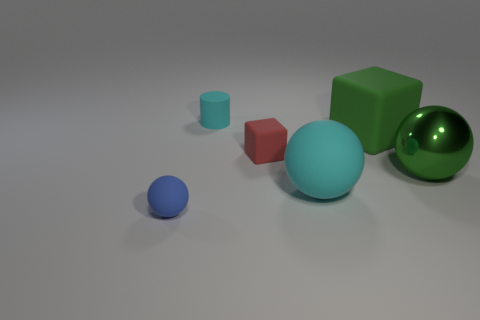What number of small things are red shiny balls or red matte cubes?
Ensure brevity in your answer.  1. Are there fewer blue balls than yellow cubes?
Provide a short and direct response. No. Is there anything else that is the same size as the green block?
Offer a very short reply. Yes. Do the cylinder and the big rubber sphere have the same color?
Your response must be concise. Yes. Is the number of tiny brown spheres greater than the number of green matte blocks?
Provide a succinct answer. No. How many other objects are there of the same color as the cylinder?
Keep it short and to the point. 1. What number of large rubber blocks are right of the small rubber thing that is to the left of the matte cylinder?
Ensure brevity in your answer.  1. Are there any tiny rubber balls behind the green shiny thing?
Your answer should be compact. No. There is a matte object in front of the cyan object that is in front of the rubber cylinder; what is its shape?
Provide a succinct answer. Sphere. Is the number of cyan balls behind the big cube less than the number of big green objects that are to the left of the tiny blue thing?
Your response must be concise. No. 